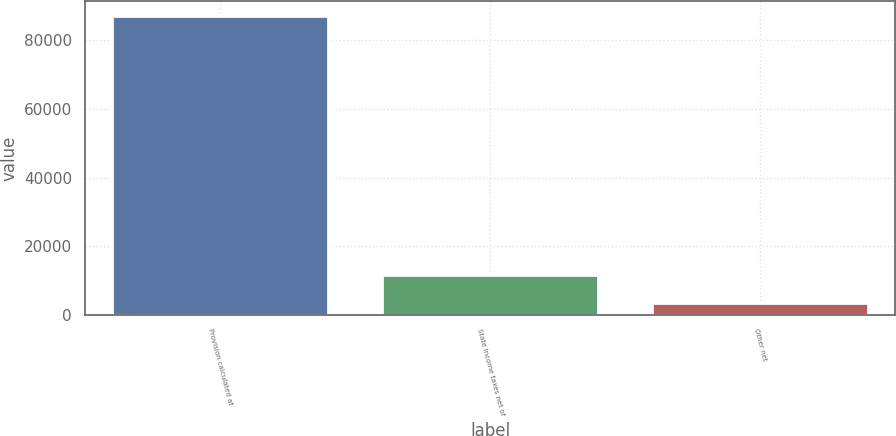Convert chart. <chart><loc_0><loc_0><loc_500><loc_500><bar_chart><fcel>Provision calculated at<fcel>State income taxes net of<fcel>Other net<nl><fcel>87071<fcel>11660<fcel>3281<nl></chart> 